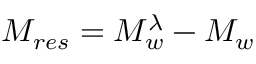<formula> <loc_0><loc_0><loc_500><loc_500>M _ { r e s } = M _ { w } ^ { \lambda } - M _ { w }</formula> 